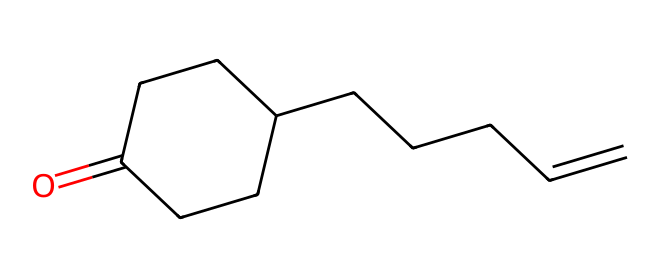What is the main functional group present in this chemical? The SMILES representation indicates a carbonyl group (C=O) at the start of the structure, which is part of a cyclic compound. This carbonyl functional group gives the chemical its characteristic properties.
Answer: carbonyl How many carbon atoms are in this chemical structure? By analyzing the SMILES representation, we can count the carbon atoms represented by 'C'. There are a total of 12 carbon atoms present in the structure.
Answer: 12 What type of compound is this chemical primarily classified as? The structure has a characteristic carbon chain along with a cyclic structure and a carbonyl group, indicating it is primarily classified as an aliphatic compound with fragrance properties.
Answer: aliphatic Does this chemical contain any double bonds? The SMILES representation shows a 'C=C' double bond in its structure, confirming the presence of a double bond between two carbon atoms, which is often found in many fragrances.
Answer: yes What is the significance of the cyclic structure in this chemical for fragrance? The cyclic structure can increase the volatility and stability of the compound, which are critical properties for the effectiveness of fragrances, allowing them to be more perceptible in the air.
Answer: volatility How does the presence of the carbonyl group affect the scent profile? The carbonyl group typically enhances the sweet, floral scent associated with many jasmine fragrances, making it more appealing and contributing to its overall fragrance profile.
Answer: enhances sweetness 